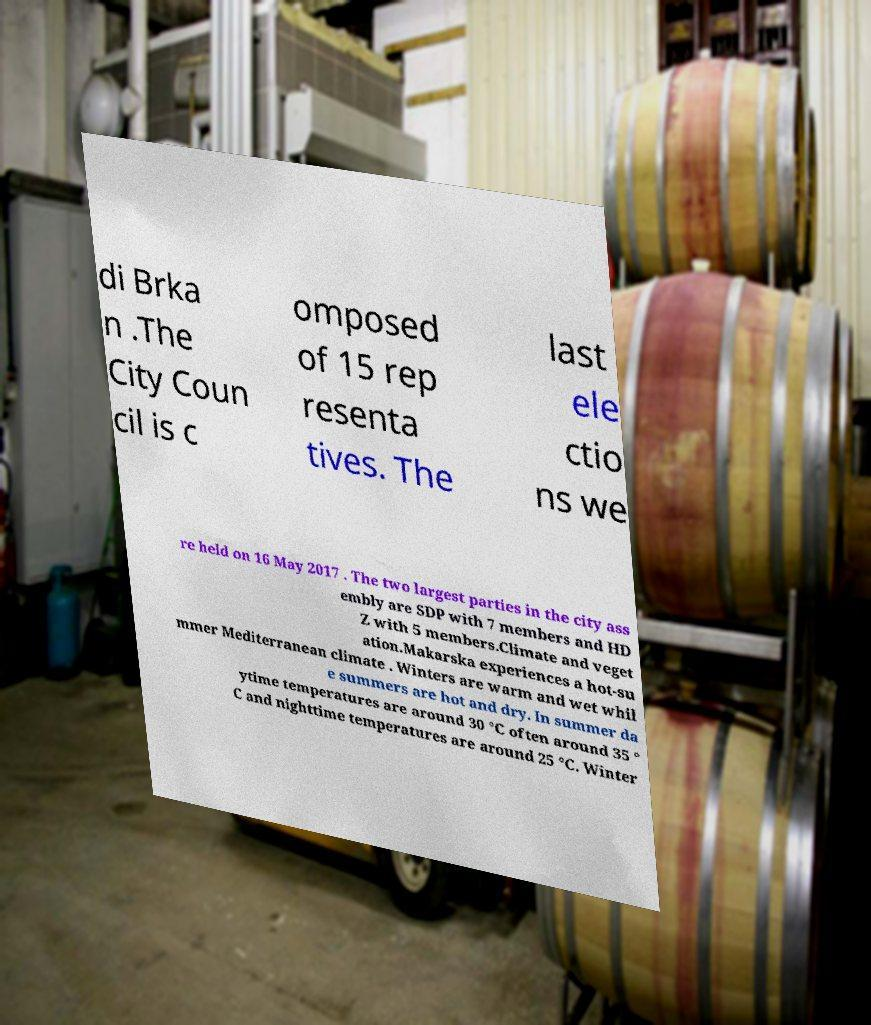Could you extract and type out the text from this image? di Brka n .The City Coun cil is c omposed of 15 rep resenta tives. The last ele ctio ns we re held on 16 May 2017 . The two largest parties in the city ass embly are SDP with 7 members and HD Z with 5 members.Climate and veget ation.Makarska experiences a hot-su mmer Mediterranean climate . Winters are warm and wet whil e summers are hot and dry. In summer da ytime temperatures are around 30 °C often around 35 ° C and nighttime temperatures are around 25 °C. Winter 